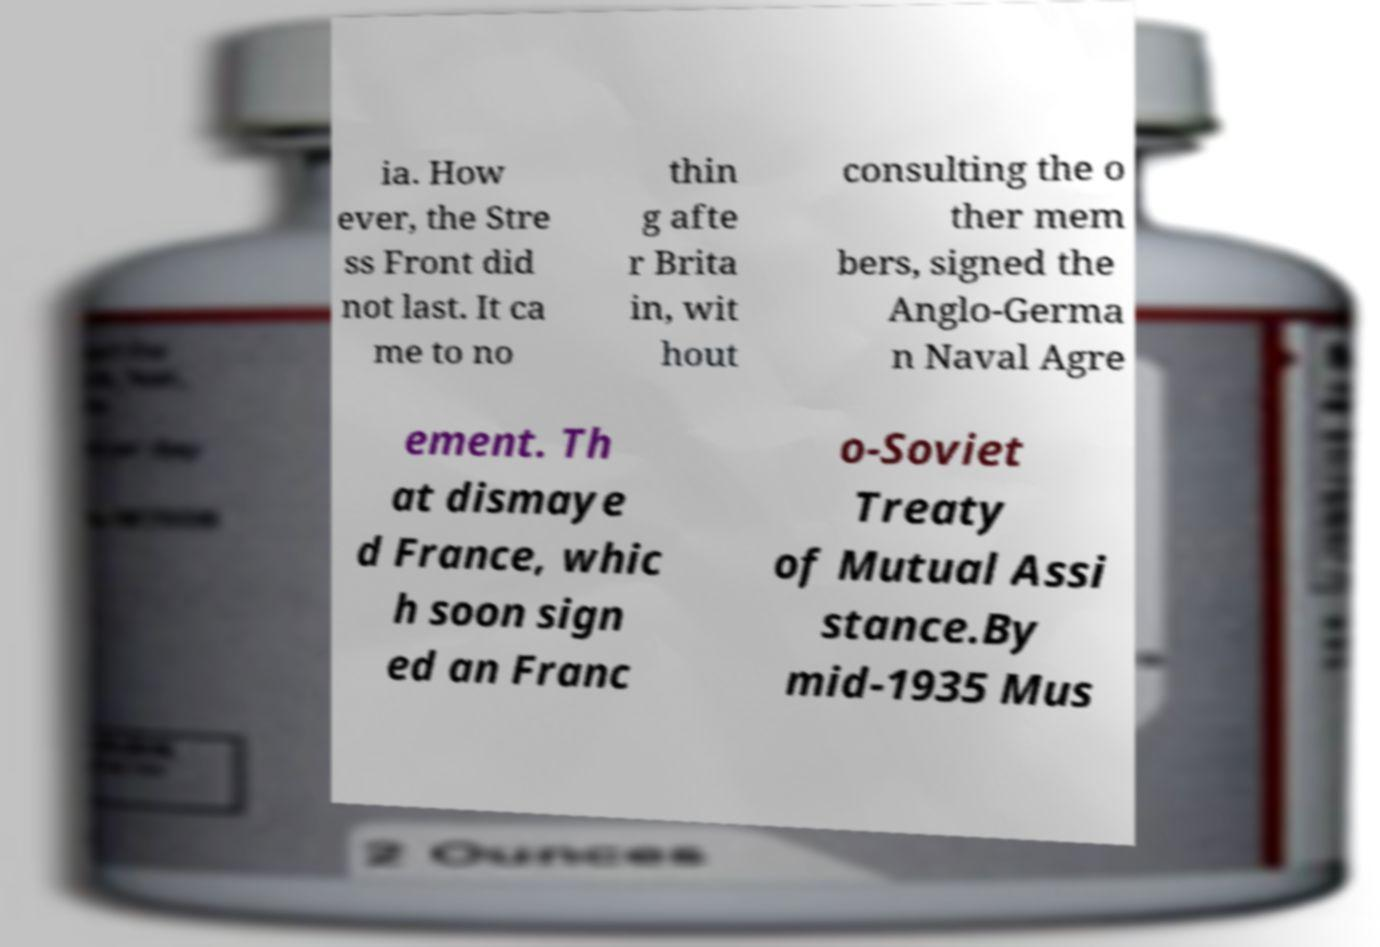Please read and relay the text visible in this image. What does it say? ia. How ever, the Stre ss Front did not last. It ca me to no thin g afte r Brita in, wit hout consulting the o ther mem bers, signed the Anglo-Germa n Naval Agre ement. Th at dismaye d France, whic h soon sign ed an Franc o-Soviet Treaty of Mutual Assi stance.By mid-1935 Mus 